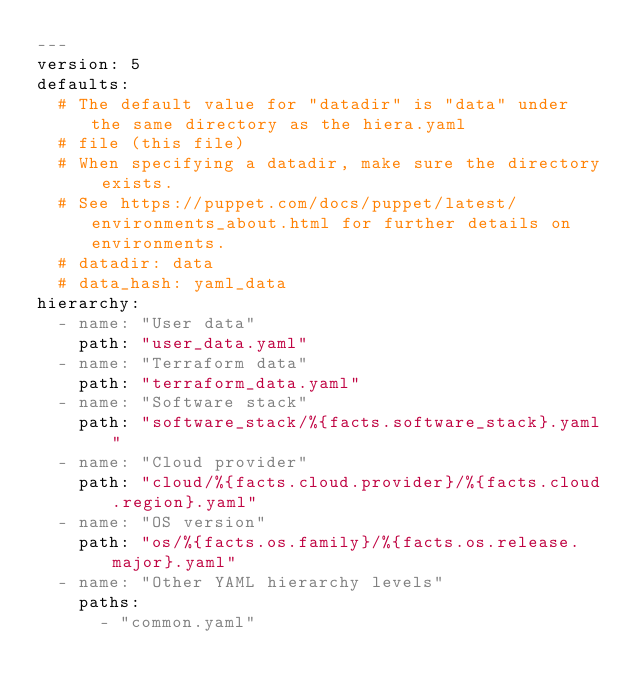<code> <loc_0><loc_0><loc_500><loc_500><_YAML_>---
version: 5
defaults:
  # The default value for "datadir" is "data" under the same directory as the hiera.yaml
  # file (this file)
  # When specifying a datadir, make sure the directory exists.
  # See https://puppet.com/docs/puppet/latest/environments_about.html for further details on environments.
  # datadir: data
  # data_hash: yaml_data
hierarchy:
  - name: "User data"
    path: "user_data.yaml"
  - name: "Terraform data"
    path: "terraform_data.yaml"
  - name: "Software stack"
    path: "software_stack/%{facts.software_stack}.yaml"
  - name: "Cloud provider"
    path: "cloud/%{facts.cloud.provider}/%{facts.cloud.region}.yaml"
  - name: "OS version"
    path: "os/%{facts.os.family}/%{facts.os.release.major}.yaml"
  - name: "Other YAML hierarchy levels"
    paths:
      - "common.yaml"
</code> 